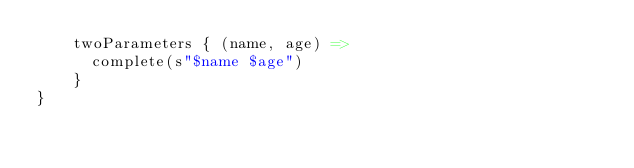Convert code to text. <code><loc_0><loc_0><loc_500><loc_500><_Scala_>    twoParameters { (name, age) =>
      complete(s"$name $age")
    }
}
</code> 